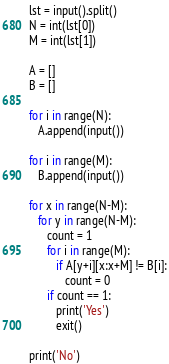<code> <loc_0><loc_0><loc_500><loc_500><_Python_>lst = input().split()
N = int(lst[0])
M = int(lst[1])

A = []
B = []

for i in range(N):
   A.append(input())

for i in range(M):
   B.append(input())

for x in range(N-M):
   for y in range(N-M):
      count = 1
      for i in range(M):
         if A[y+i][x:x+M] != B[i]:
            count = 0
      if count == 1:
         print('Yes')
         exit()

print('No')</code> 